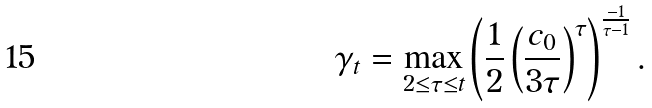<formula> <loc_0><loc_0><loc_500><loc_500>\gamma _ { t } = \max _ { 2 \leq \tau \leq t } \left ( \frac { 1 } { 2 } \left ( \frac { c _ { 0 } } { 3 \tau } \right ) ^ { \tau } \right ) ^ { \frac { - 1 } { \tau - 1 } } .</formula> 